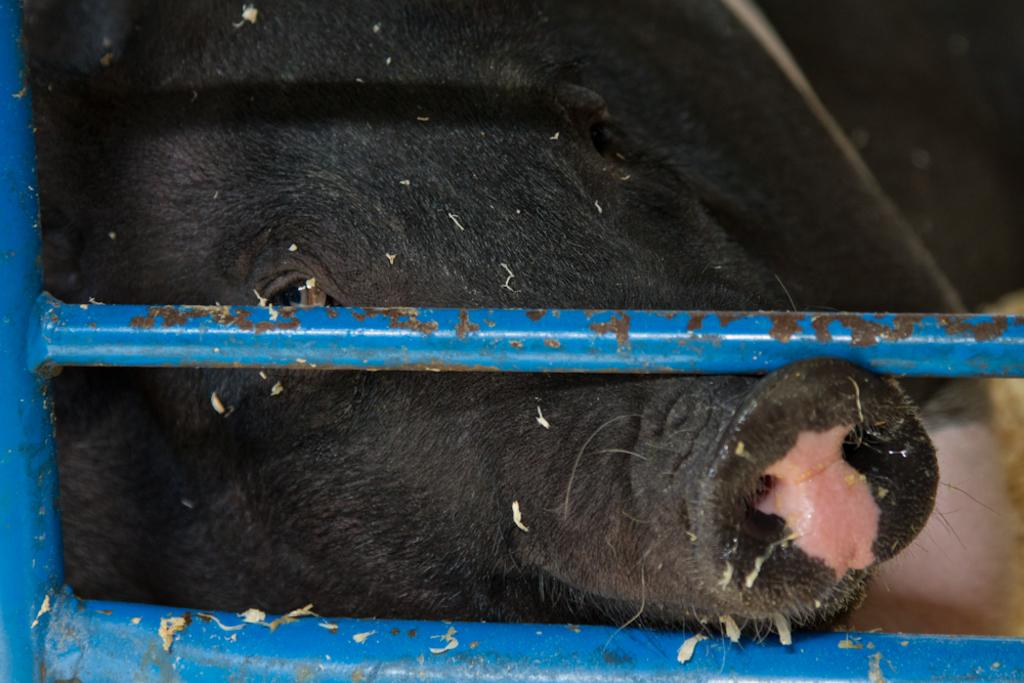What type of animal is present in the image? There is a black color pig in the image. What other objects can be seen in the image? There are blue color iron rods in the image. What type of nerve is visible in the image? There is no nerve visible in the image; it features a black pig and blue iron rods. What type of crime is being committed in the image? There is no crime being committed in the image; it features a black pig and blue iron rods. 